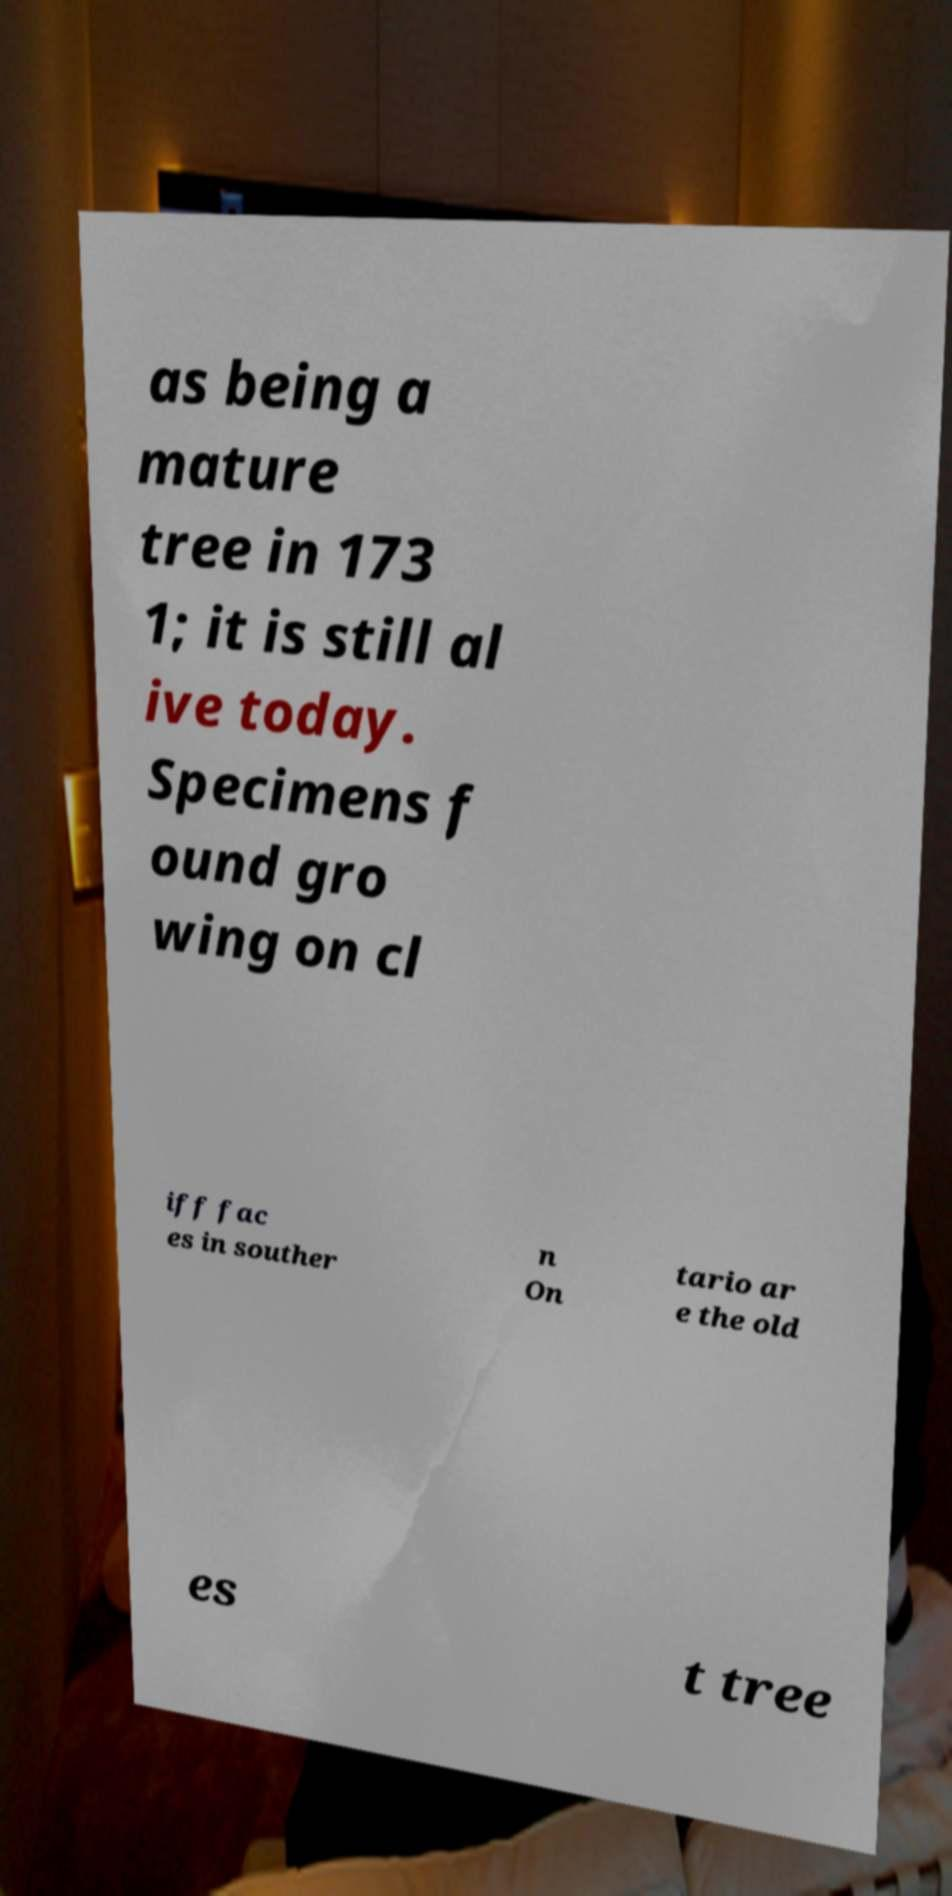I need the written content from this picture converted into text. Can you do that? as being a mature tree in 173 1; it is still al ive today. Specimens f ound gro wing on cl iff fac es in souther n On tario ar e the old es t tree 